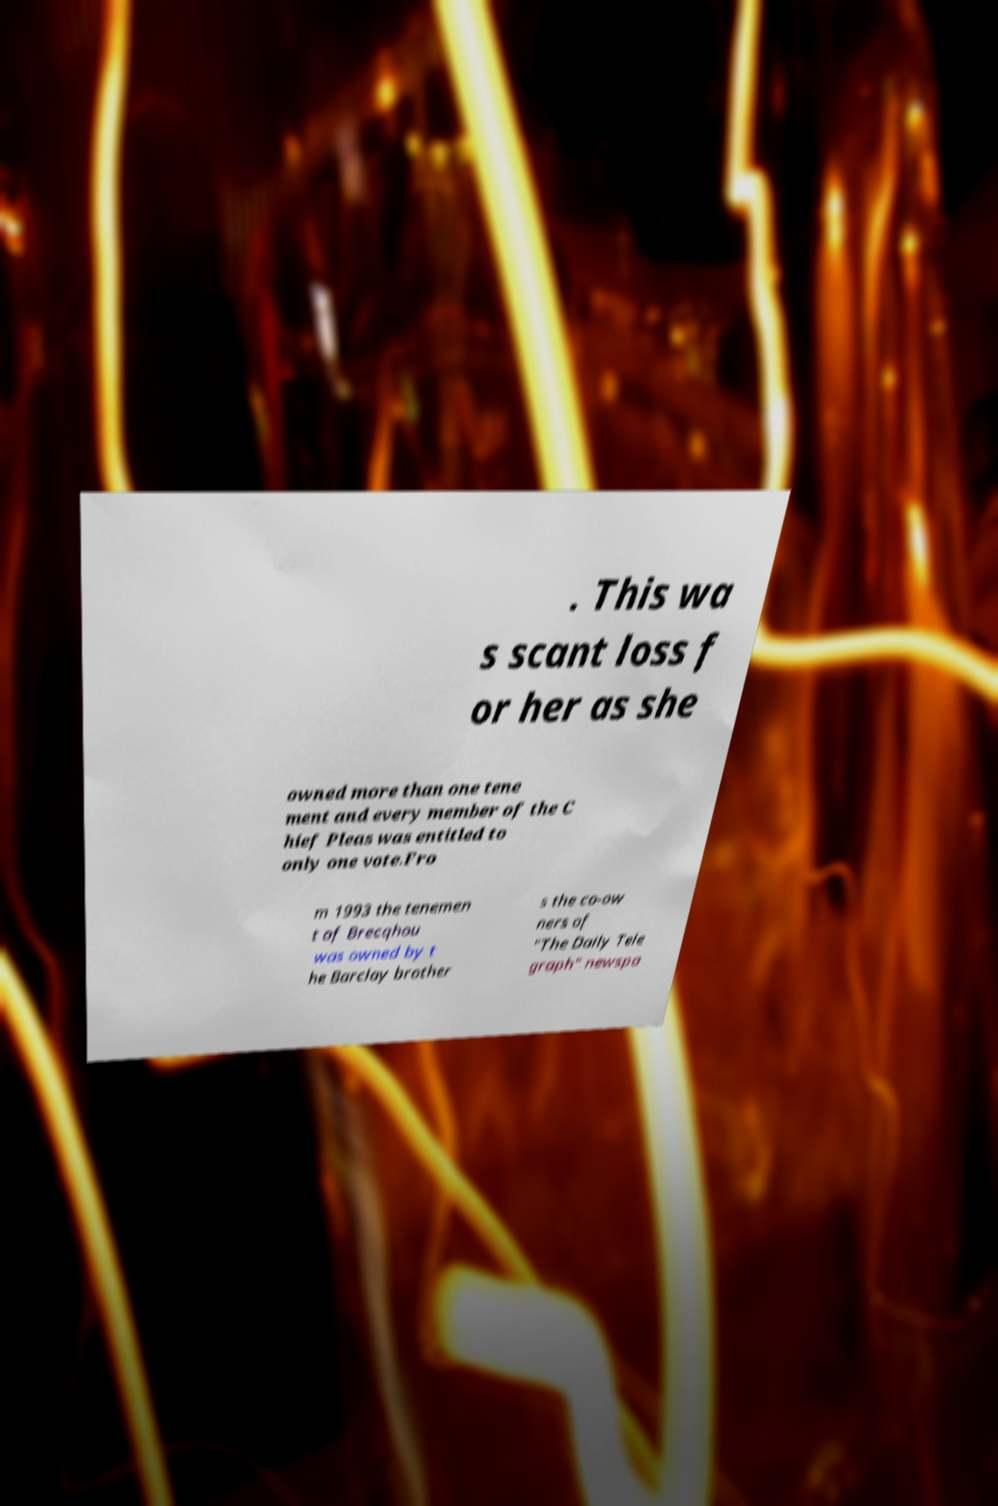Please identify and transcribe the text found in this image. . This wa s scant loss f or her as she owned more than one tene ment and every member of the C hief Pleas was entitled to only one vote.Fro m 1993 the tenemen t of Brecqhou was owned by t he Barclay brother s the co-ow ners of "The Daily Tele graph" newspa 